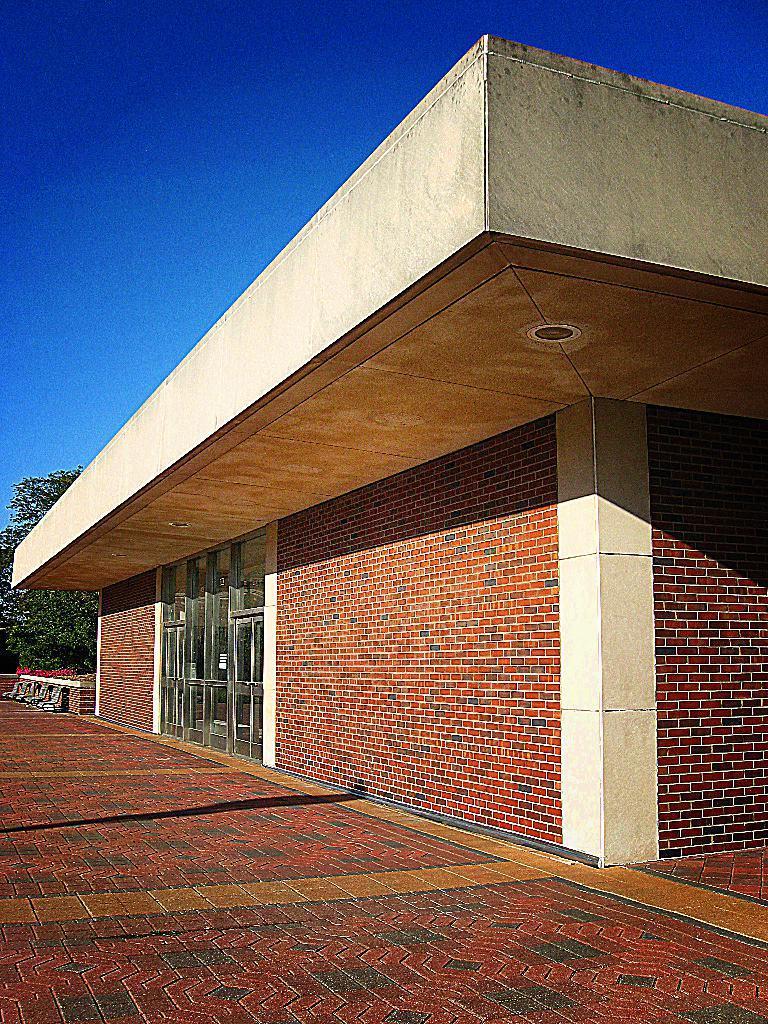Could you give a brief overview of what you see in this image? In this picture we can see a building, in the background we can find few trees. 